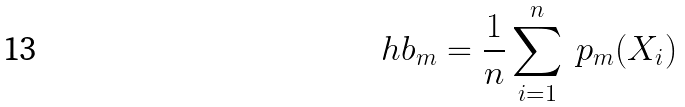Convert formula to latex. <formula><loc_0><loc_0><loc_500><loc_500>\ h b _ { m } = \frac { 1 } { n } \sum _ { i = 1 } ^ { n } \ p _ { m } ( X _ { i } )</formula> 